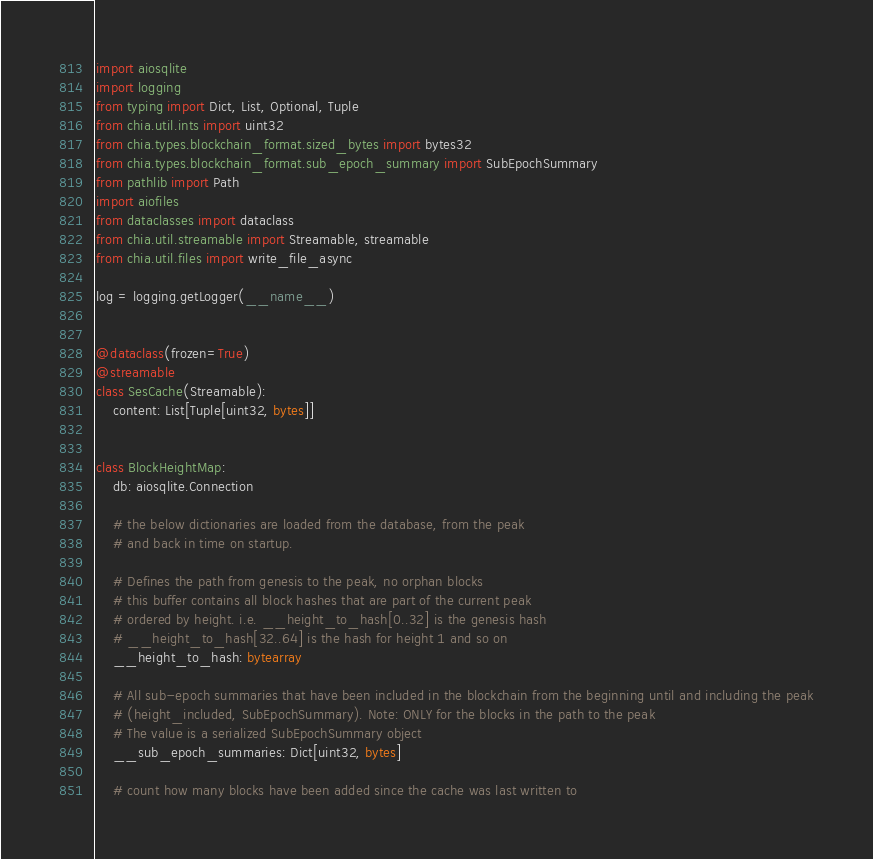Convert code to text. <code><loc_0><loc_0><loc_500><loc_500><_Python_>import aiosqlite
import logging
from typing import Dict, List, Optional, Tuple
from chia.util.ints import uint32
from chia.types.blockchain_format.sized_bytes import bytes32
from chia.types.blockchain_format.sub_epoch_summary import SubEpochSummary
from pathlib import Path
import aiofiles
from dataclasses import dataclass
from chia.util.streamable import Streamable, streamable
from chia.util.files import write_file_async

log = logging.getLogger(__name__)


@dataclass(frozen=True)
@streamable
class SesCache(Streamable):
    content: List[Tuple[uint32, bytes]]


class BlockHeightMap:
    db: aiosqlite.Connection

    # the below dictionaries are loaded from the database, from the peak
    # and back in time on startup.

    # Defines the path from genesis to the peak, no orphan blocks
    # this buffer contains all block hashes that are part of the current peak
    # ordered by height. i.e. __height_to_hash[0..32] is the genesis hash
    # __height_to_hash[32..64] is the hash for height 1 and so on
    __height_to_hash: bytearray

    # All sub-epoch summaries that have been included in the blockchain from the beginning until and including the peak
    # (height_included, SubEpochSummary). Note: ONLY for the blocks in the path to the peak
    # The value is a serialized SubEpochSummary object
    __sub_epoch_summaries: Dict[uint32, bytes]

    # count how many blocks have been added since the cache was last written to</code> 